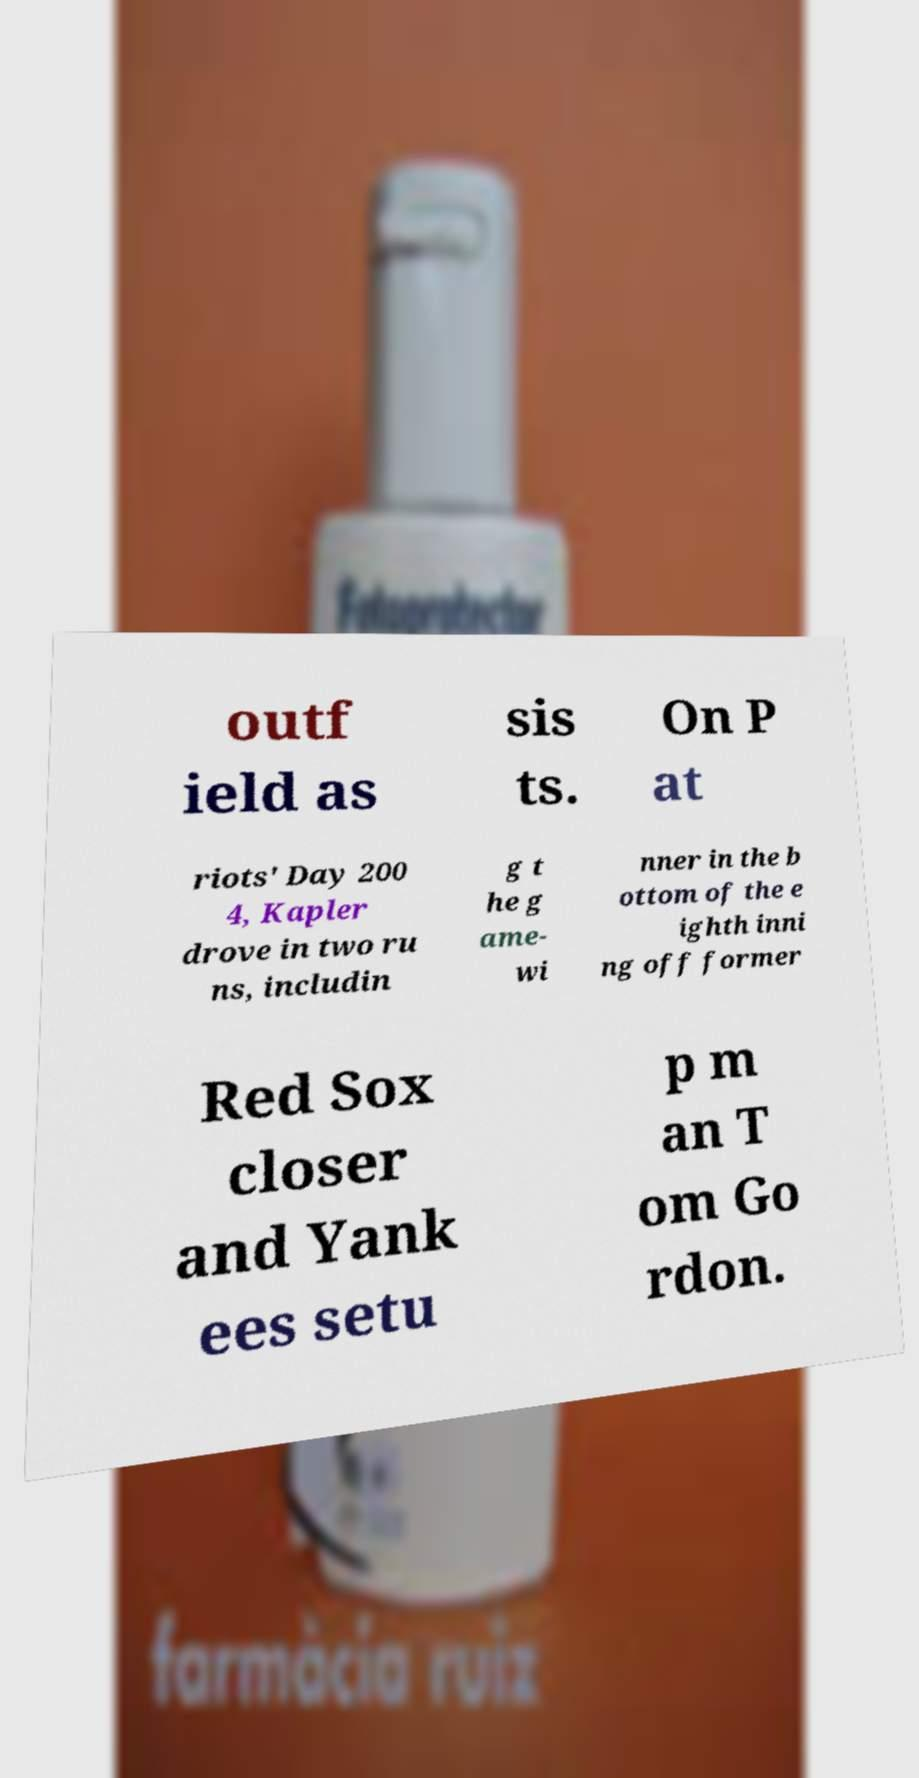I need the written content from this picture converted into text. Can you do that? outf ield as sis ts. On P at riots' Day 200 4, Kapler drove in two ru ns, includin g t he g ame- wi nner in the b ottom of the e ighth inni ng off former Red Sox closer and Yank ees setu p m an T om Go rdon. 